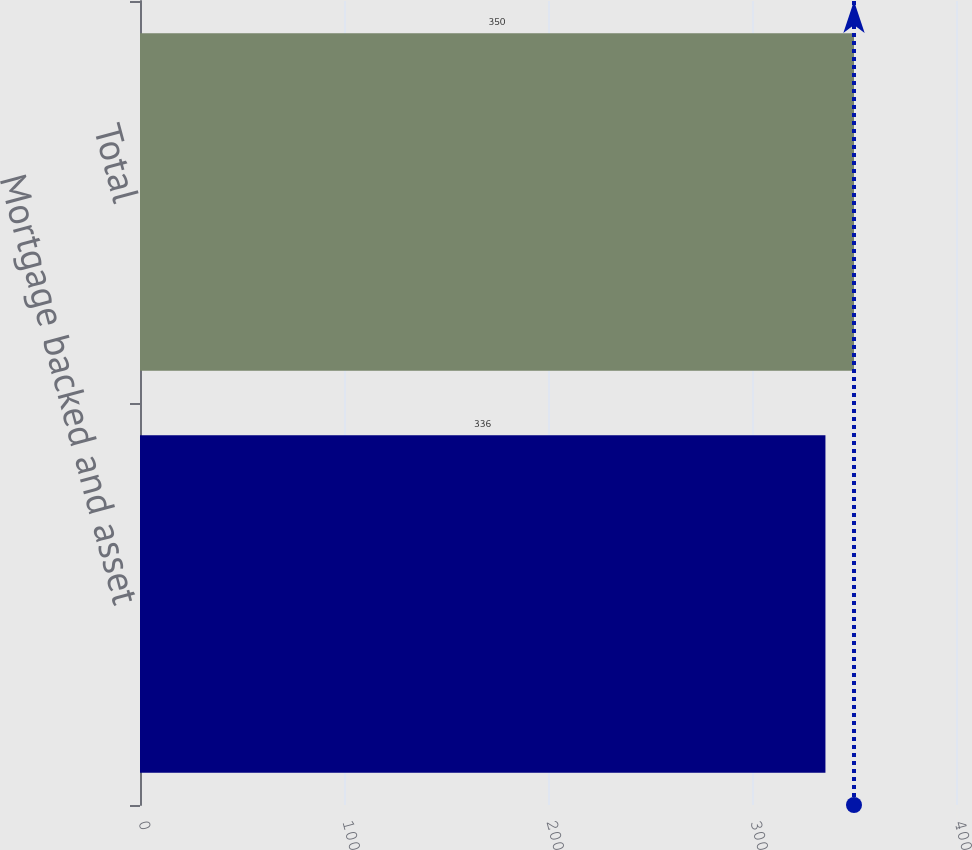Convert chart. <chart><loc_0><loc_0><loc_500><loc_500><bar_chart><fcel>Mortgage backed and asset<fcel>Total<nl><fcel>336<fcel>350<nl></chart> 